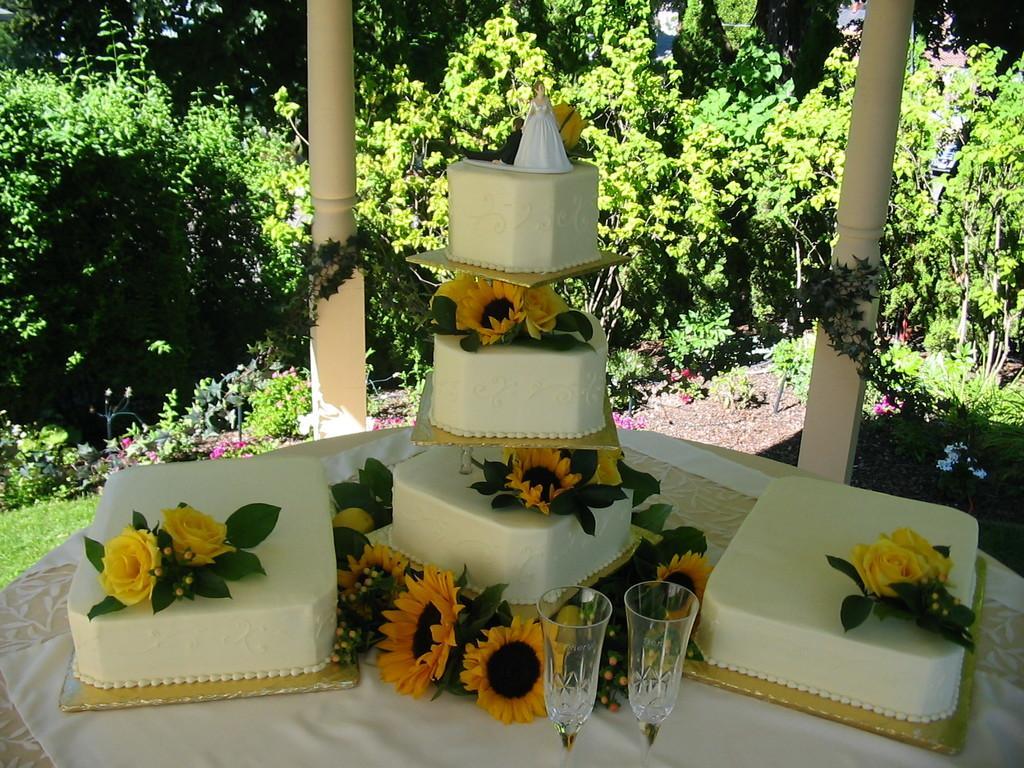Can you describe this image briefly? In this image, we can see a table contains cakes, flowers and glasses. There are some plants and poles in the middle of the image. 